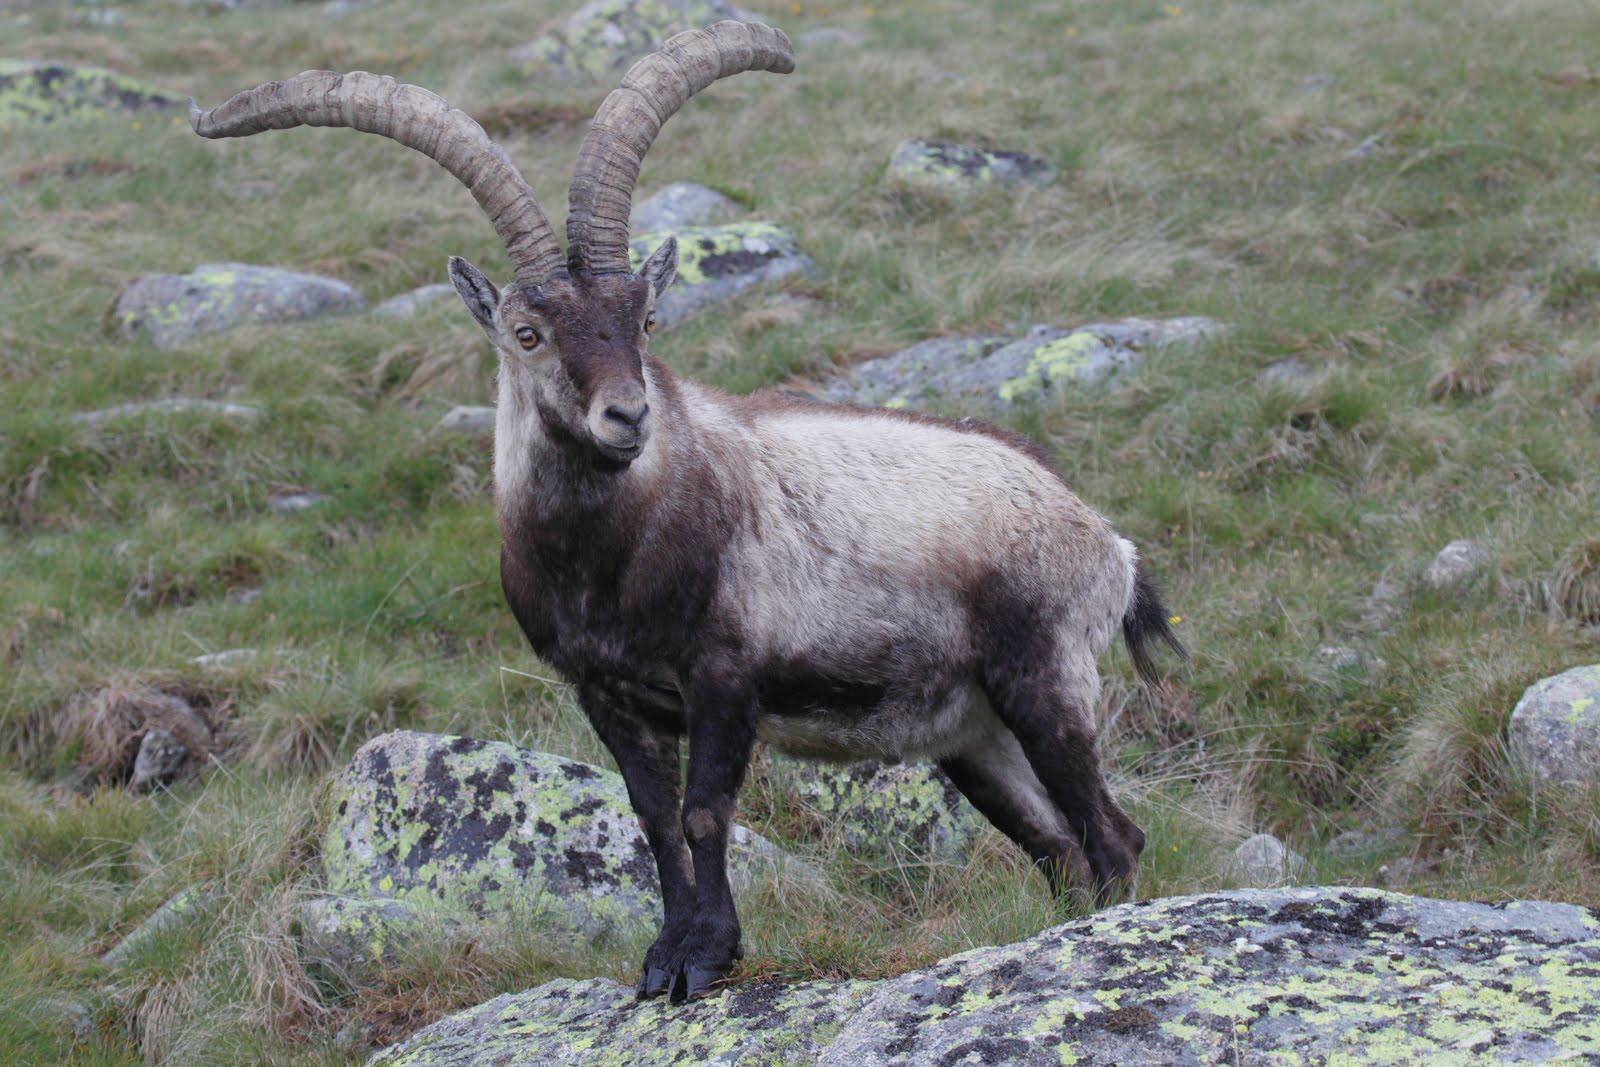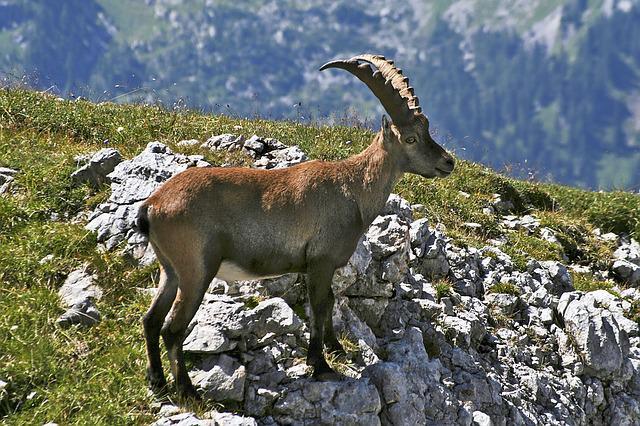The first image is the image on the left, the second image is the image on the right. Examine the images to the left and right. Is the description "The left and right image contains the same number of goats with one sitting." accurate? Answer yes or no. No. The first image is the image on the left, the second image is the image on the right. Analyze the images presented: Is the assertion "The left image contains one reclining long-horned animal with its front legs folded under and its head turned to face the camera." valid? Answer yes or no. No. 